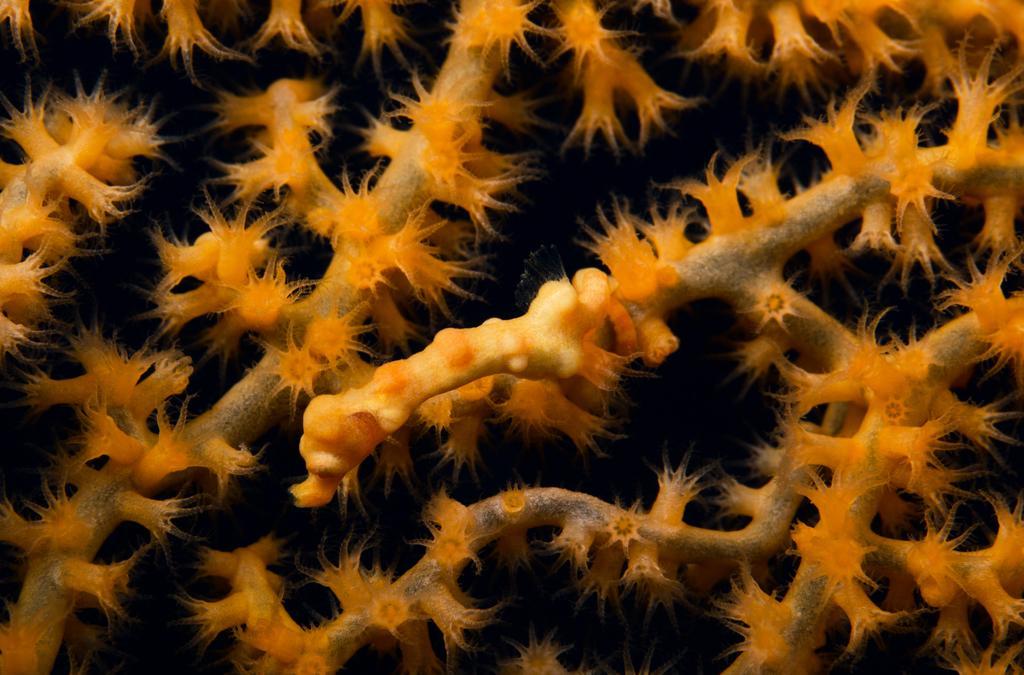Describe this image in one or two sentences. In the image we can see underwater plants. 